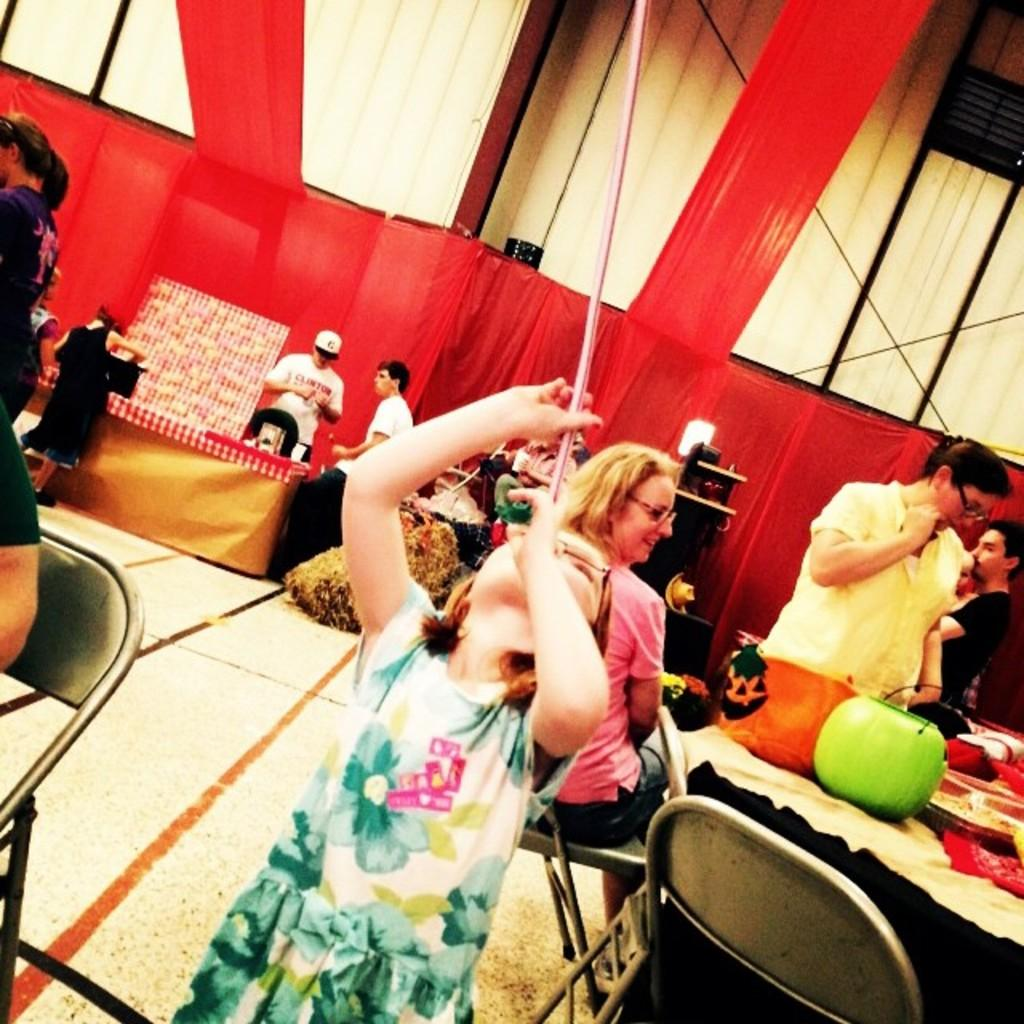What is happening around the table in the image? There are persons sitting and standing around a table. What objects can be seen on the table? There are pumpkins on the table. What color is the wall in the background? There is a red color wall in the background. Where are some of the persons standing in relation to the red wall? There are persons standing in front of the red color wall. What type of bone can be seen in the image? There is no bone present in the image. Is the event taking place in a church or a hall? The provided facts do not mention a church or a hall, so it cannot be determined from the image. 